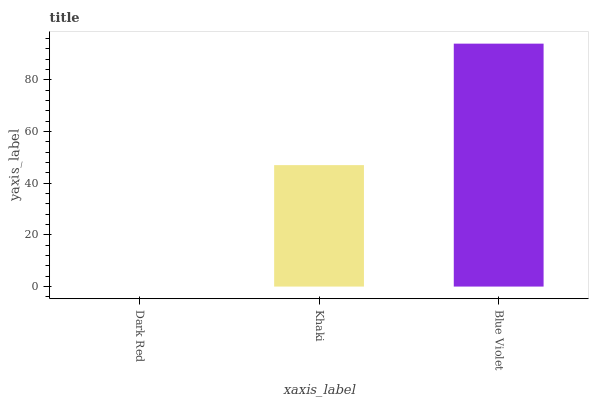Is Dark Red the minimum?
Answer yes or no. Yes. Is Blue Violet the maximum?
Answer yes or no. Yes. Is Khaki the minimum?
Answer yes or no. No. Is Khaki the maximum?
Answer yes or no. No. Is Khaki greater than Dark Red?
Answer yes or no. Yes. Is Dark Red less than Khaki?
Answer yes or no. Yes. Is Dark Red greater than Khaki?
Answer yes or no. No. Is Khaki less than Dark Red?
Answer yes or no. No. Is Khaki the high median?
Answer yes or no. Yes. Is Khaki the low median?
Answer yes or no. Yes. Is Blue Violet the high median?
Answer yes or no. No. Is Blue Violet the low median?
Answer yes or no. No. 